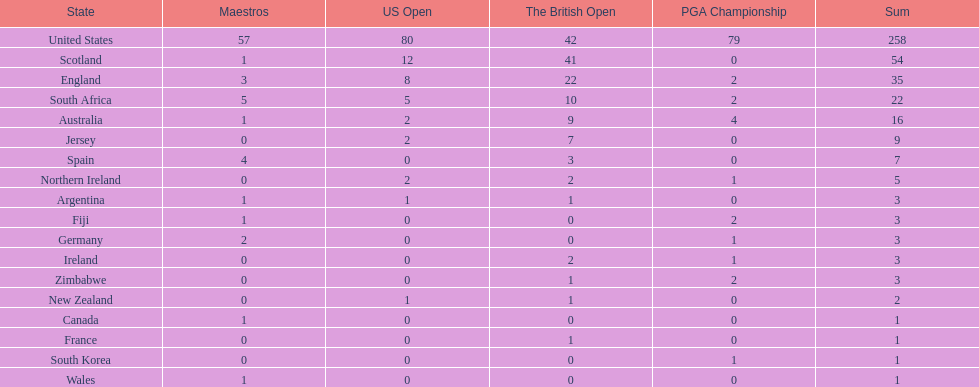What are the number of pga winning golfers that zimbabwe has? 2. 